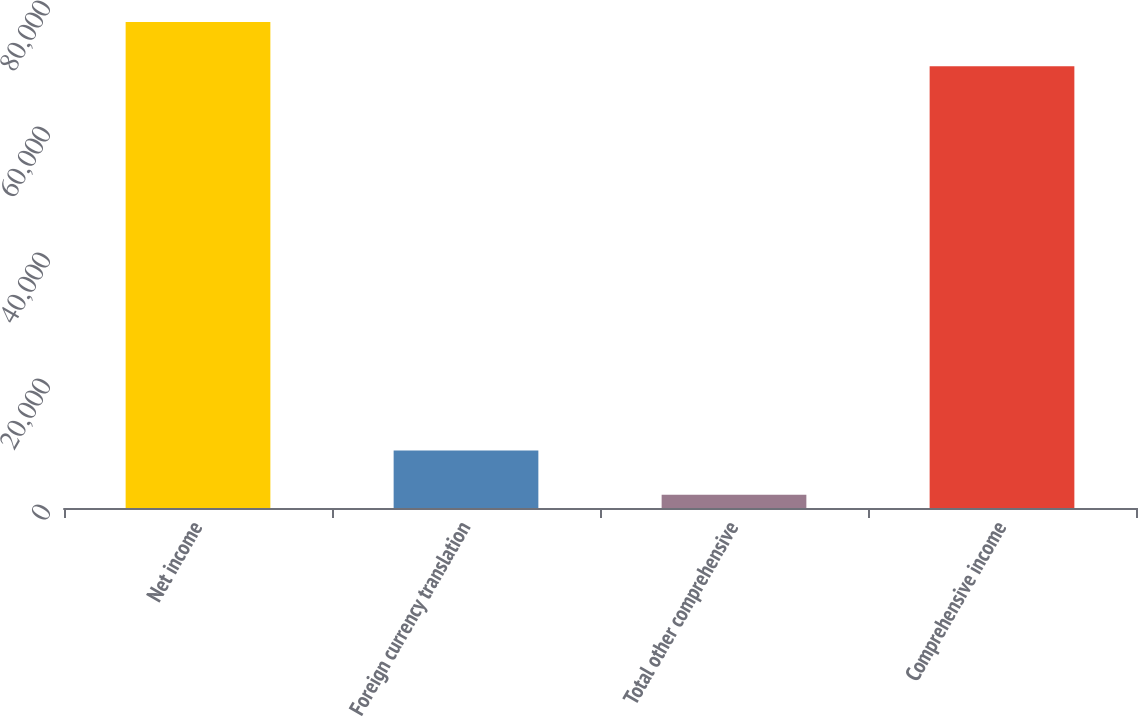Convert chart. <chart><loc_0><loc_0><loc_500><loc_500><bar_chart><fcel>Net income<fcel>Foreign currency translation<fcel>Total other comprehensive<fcel>Comprehensive income<nl><fcel>77138.6<fcel>9115.6<fcel>2103<fcel>70126<nl></chart> 